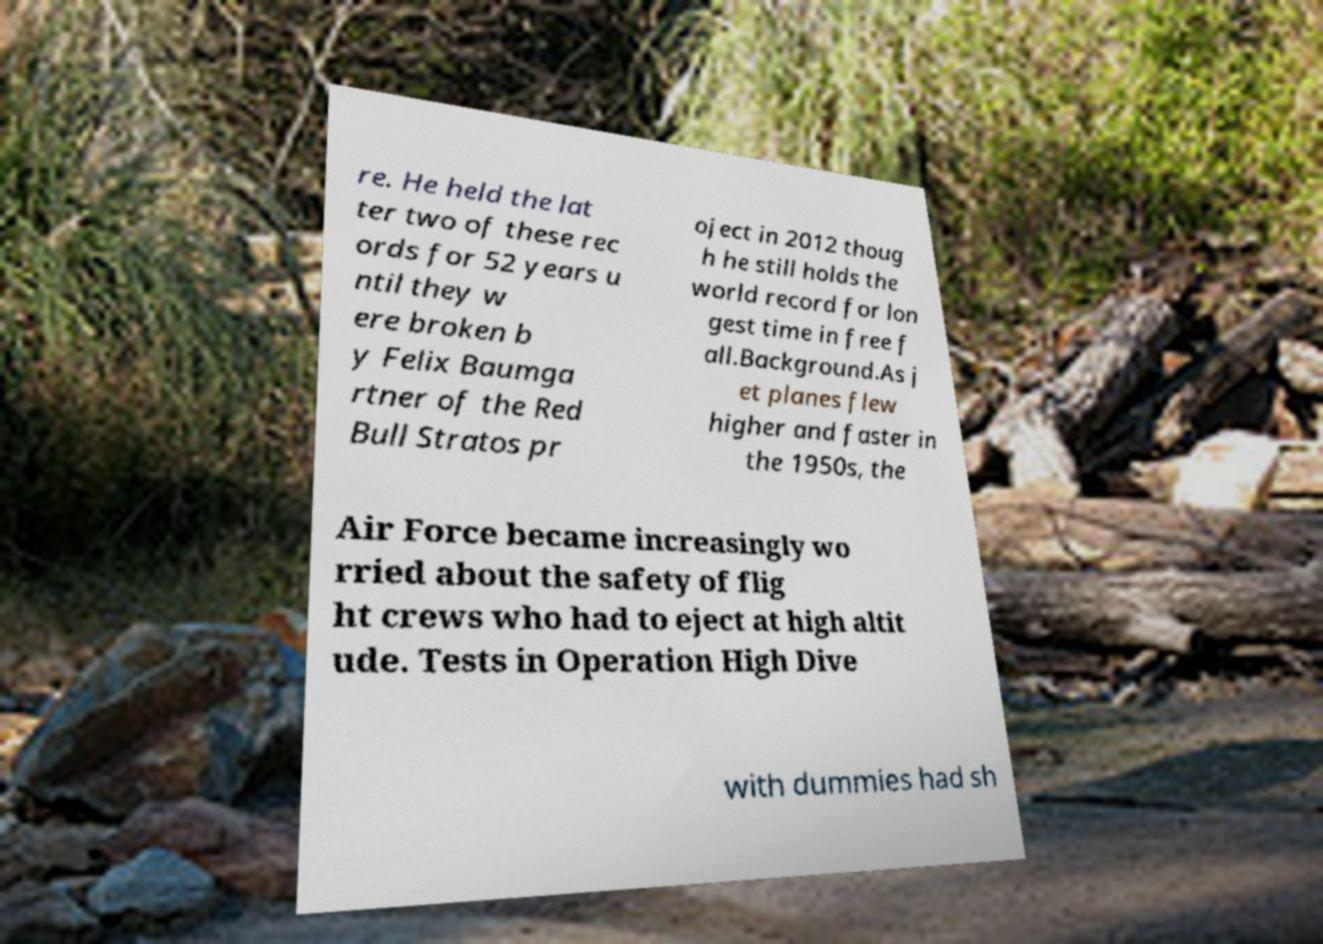What messages or text are displayed in this image? I need them in a readable, typed format. re. He held the lat ter two of these rec ords for 52 years u ntil they w ere broken b y Felix Baumga rtner of the Red Bull Stratos pr oject in 2012 thoug h he still holds the world record for lon gest time in free f all.Background.As j et planes flew higher and faster in the 1950s, the Air Force became increasingly wo rried about the safety of flig ht crews who had to eject at high altit ude. Tests in Operation High Dive with dummies had sh 